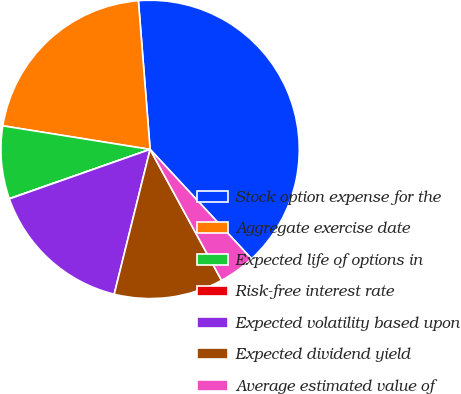<chart> <loc_0><loc_0><loc_500><loc_500><pie_chart><fcel>Stock option expense for the<fcel>Aggregate exercise date<fcel>Expected life of options in<fcel>Risk-free interest rate<fcel>Expected volatility based upon<fcel>Expected dividend yield<fcel>Average estimated value of<nl><fcel>39.35%<fcel>21.22%<fcel>7.89%<fcel>0.02%<fcel>15.75%<fcel>11.82%<fcel>3.95%<nl></chart> 